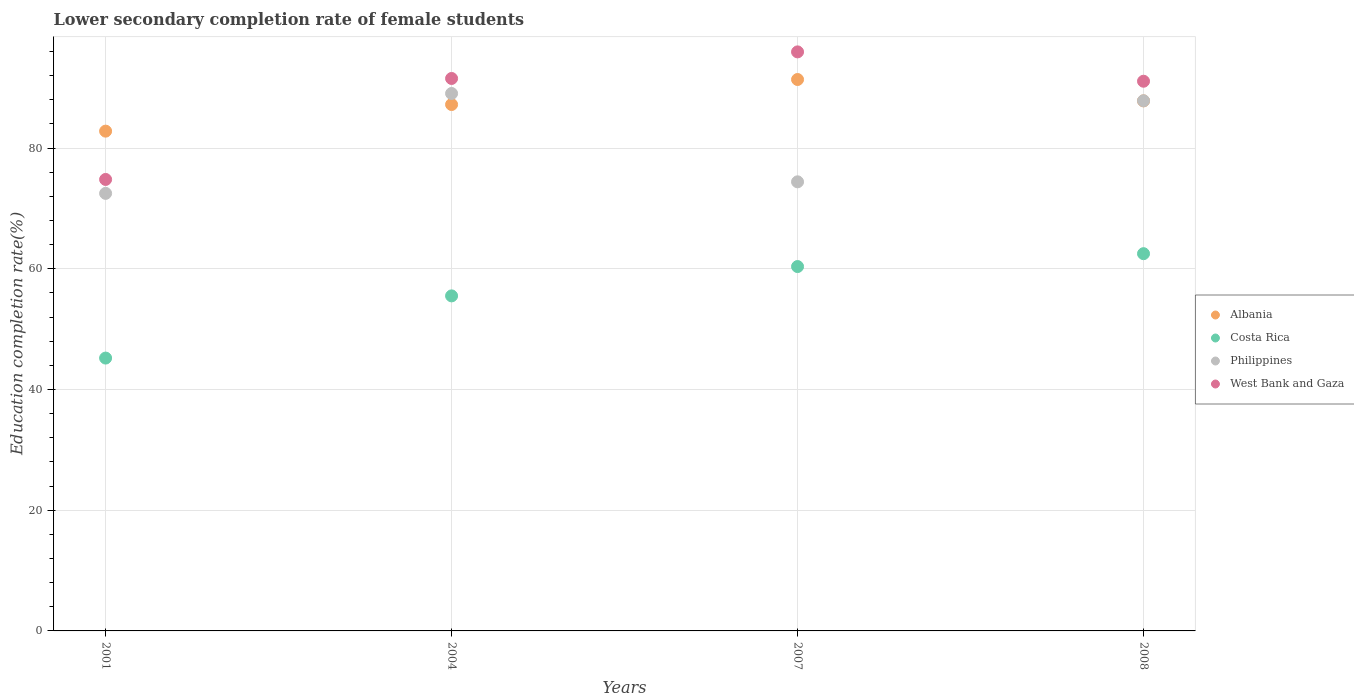Is the number of dotlines equal to the number of legend labels?
Give a very brief answer. Yes. What is the lower secondary completion rate of female students in Albania in 2008?
Offer a terse response. 87.83. Across all years, what is the maximum lower secondary completion rate of female students in Albania?
Ensure brevity in your answer.  91.37. Across all years, what is the minimum lower secondary completion rate of female students in Albania?
Ensure brevity in your answer.  82.82. In which year was the lower secondary completion rate of female students in Costa Rica maximum?
Offer a terse response. 2008. In which year was the lower secondary completion rate of female students in West Bank and Gaza minimum?
Provide a short and direct response. 2001. What is the total lower secondary completion rate of female students in West Bank and Gaza in the graph?
Offer a very short reply. 353.39. What is the difference between the lower secondary completion rate of female students in Philippines in 2001 and that in 2004?
Make the answer very short. -16.55. What is the difference between the lower secondary completion rate of female students in West Bank and Gaza in 2004 and the lower secondary completion rate of female students in Philippines in 2001?
Provide a succinct answer. 19.04. What is the average lower secondary completion rate of female students in West Bank and Gaza per year?
Your answer should be compact. 88.35. In the year 2001, what is the difference between the lower secondary completion rate of female students in Albania and lower secondary completion rate of female students in West Bank and Gaza?
Your response must be concise. 8. What is the ratio of the lower secondary completion rate of female students in Albania in 2004 to that in 2008?
Your answer should be compact. 0.99. Is the lower secondary completion rate of female students in Costa Rica in 2007 less than that in 2008?
Provide a short and direct response. Yes. Is the difference between the lower secondary completion rate of female students in Albania in 2001 and 2008 greater than the difference between the lower secondary completion rate of female students in West Bank and Gaza in 2001 and 2008?
Keep it short and to the point. Yes. What is the difference between the highest and the second highest lower secondary completion rate of female students in Philippines?
Ensure brevity in your answer.  1.2. What is the difference between the highest and the lowest lower secondary completion rate of female students in Philippines?
Make the answer very short. 16.55. Is the sum of the lower secondary completion rate of female students in West Bank and Gaza in 2001 and 2004 greater than the maximum lower secondary completion rate of female students in Costa Rica across all years?
Provide a short and direct response. Yes. Is it the case that in every year, the sum of the lower secondary completion rate of female students in Philippines and lower secondary completion rate of female students in Albania  is greater than the lower secondary completion rate of female students in West Bank and Gaza?
Make the answer very short. Yes. Does the lower secondary completion rate of female students in Philippines monotonically increase over the years?
Your answer should be very brief. No. Is the lower secondary completion rate of female students in West Bank and Gaza strictly greater than the lower secondary completion rate of female students in Albania over the years?
Give a very brief answer. No. Does the graph contain any zero values?
Provide a short and direct response. No. Where does the legend appear in the graph?
Provide a succinct answer. Center right. How many legend labels are there?
Your response must be concise. 4. What is the title of the graph?
Offer a terse response. Lower secondary completion rate of female students. What is the label or title of the Y-axis?
Make the answer very short. Education completion rate(%). What is the Education completion rate(%) of Albania in 2001?
Your response must be concise. 82.82. What is the Education completion rate(%) of Costa Rica in 2001?
Provide a short and direct response. 45.21. What is the Education completion rate(%) in Philippines in 2001?
Make the answer very short. 72.5. What is the Education completion rate(%) of West Bank and Gaza in 2001?
Your answer should be very brief. 74.81. What is the Education completion rate(%) in Albania in 2004?
Ensure brevity in your answer.  87.23. What is the Education completion rate(%) in Costa Rica in 2004?
Make the answer very short. 55.52. What is the Education completion rate(%) in Philippines in 2004?
Provide a short and direct response. 89.05. What is the Education completion rate(%) in West Bank and Gaza in 2004?
Ensure brevity in your answer.  91.54. What is the Education completion rate(%) in Albania in 2007?
Your answer should be compact. 91.37. What is the Education completion rate(%) of Costa Rica in 2007?
Keep it short and to the point. 60.38. What is the Education completion rate(%) in Philippines in 2007?
Make the answer very short. 74.42. What is the Education completion rate(%) in West Bank and Gaza in 2007?
Your answer should be very brief. 95.95. What is the Education completion rate(%) in Albania in 2008?
Offer a very short reply. 87.83. What is the Education completion rate(%) of Costa Rica in 2008?
Provide a succinct answer. 62.51. What is the Education completion rate(%) of Philippines in 2008?
Your answer should be very brief. 87.85. What is the Education completion rate(%) of West Bank and Gaza in 2008?
Provide a succinct answer. 91.09. Across all years, what is the maximum Education completion rate(%) in Albania?
Your answer should be compact. 91.37. Across all years, what is the maximum Education completion rate(%) in Costa Rica?
Your answer should be compact. 62.51. Across all years, what is the maximum Education completion rate(%) in Philippines?
Provide a short and direct response. 89.05. Across all years, what is the maximum Education completion rate(%) of West Bank and Gaza?
Provide a short and direct response. 95.95. Across all years, what is the minimum Education completion rate(%) of Albania?
Provide a succinct answer. 82.82. Across all years, what is the minimum Education completion rate(%) in Costa Rica?
Keep it short and to the point. 45.21. Across all years, what is the minimum Education completion rate(%) in Philippines?
Offer a very short reply. 72.5. Across all years, what is the minimum Education completion rate(%) of West Bank and Gaza?
Your response must be concise. 74.81. What is the total Education completion rate(%) in Albania in the graph?
Offer a terse response. 349.25. What is the total Education completion rate(%) of Costa Rica in the graph?
Keep it short and to the point. 223.62. What is the total Education completion rate(%) in Philippines in the graph?
Keep it short and to the point. 323.83. What is the total Education completion rate(%) in West Bank and Gaza in the graph?
Keep it short and to the point. 353.39. What is the difference between the Education completion rate(%) in Albania in 2001 and that in 2004?
Give a very brief answer. -4.41. What is the difference between the Education completion rate(%) of Costa Rica in 2001 and that in 2004?
Offer a very short reply. -10.31. What is the difference between the Education completion rate(%) in Philippines in 2001 and that in 2004?
Your answer should be compact. -16.55. What is the difference between the Education completion rate(%) in West Bank and Gaza in 2001 and that in 2004?
Make the answer very short. -16.73. What is the difference between the Education completion rate(%) in Albania in 2001 and that in 2007?
Give a very brief answer. -8.56. What is the difference between the Education completion rate(%) in Costa Rica in 2001 and that in 2007?
Give a very brief answer. -15.17. What is the difference between the Education completion rate(%) in Philippines in 2001 and that in 2007?
Offer a very short reply. -1.91. What is the difference between the Education completion rate(%) in West Bank and Gaza in 2001 and that in 2007?
Give a very brief answer. -21.14. What is the difference between the Education completion rate(%) in Albania in 2001 and that in 2008?
Your answer should be very brief. -5.02. What is the difference between the Education completion rate(%) in Costa Rica in 2001 and that in 2008?
Provide a short and direct response. -17.3. What is the difference between the Education completion rate(%) in Philippines in 2001 and that in 2008?
Provide a short and direct response. -15.35. What is the difference between the Education completion rate(%) of West Bank and Gaza in 2001 and that in 2008?
Keep it short and to the point. -16.27. What is the difference between the Education completion rate(%) of Albania in 2004 and that in 2007?
Your response must be concise. -4.15. What is the difference between the Education completion rate(%) of Costa Rica in 2004 and that in 2007?
Provide a short and direct response. -4.86. What is the difference between the Education completion rate(%) in Philippines in 2004 and that in 2007?
Your answer should be compact. 14.64. What is the difference between the Education completion rate(%) in West Bank and Gaza in 2004 and that in 2007?
Your response must be concise. -4.41. What is the difference between the Education completion rate(%) in Albania in 2004 and that in 2008?
Make the answer very short. -0.6. What is the difference between the Education completion rate(%) in Costa Rica in 2004 and that in 2008?
Your answer should be very brief. -6.99. What is the difference between the Education completion rate(%) of Philippines in 2004 and that in 2008?
Keep it short and to the point. 1.2. What is the difference between the Education completion rate(%) in West Bank and Gaza in 2004 and that in 2008?
Give a very brief answer. 0.46. What is the difference between the Education completion rate(%) in Albania in 2007 and that in 2008?
Keep it short and to the point. 3.54. What is the difference between the Education completion rate(%) in Costa Rica in 2007 and that in 2008?
Ensure brevity in your answer.  -2.13. What is the difference between the Education completion rate(%) in Philippines in 2007 and that in 2008?
Your answer should be very brief. -13.43. What is the difference between the Education completion rate(%) in West Bank and Gaza in 2007 and that in 2008?
Give a very brief answer. 4.86. What is the difference between the Education completion rate(%) in Albania in 2001 and the Education completion rate(%) in Costa Rica in 2004?
Give a very brief answer. 27.3. What is the difference between the Education completion rate(%) of Albania in 2001 and the Education completion rate(%) of Philippines in 2004?
Your answer should be very brief. -6.24. What is the difference between the Education completion rate(%) in Albania in 2001 and the Education completion rate(%) in West Bank and Gaza in 2004?
Give a very brief answer. -8.73. What is the difference between the Education completion rate(%) in Costa Rica in 2001 and the Education completion rate(%) in Philippines in 2004?
Your answer should be compact. -43.84. What is the difference between the Education completion rate(%) in Costa Rica in 2001 and the Education completion rate(%) in West Bank and Gaza in 2004?
Keep it short and to the point. -46.33. What is the difference between the Education completion rate(%) in Philippines in 2001 and the Education completion rate(%) in West Bank and Gaza in 2004?
Provide a succinct answer. -19.04. What is the difference between the Education completion rate(%) of Albania in 2001 and the Education completion rate(%) of Costa Rica in 2007?
Offer a terse response. 22.44. What is the difference between the Education completion rate(%) in Albania in 2001 and the Education completion rate(%) in Philippines in 2007?
Ensure brevity in your answer.  8.4. What is the difference between the Education completion rate(%) in Albania in 2001 and the Education completion rate(%) in West Bank and Gaza in 2007?
Provide a succinct answer. -13.13. What is the difference between the Education completion rate(%) in Costa Rica in 2001 and the Education completion rate(%) in Philippines in 2007?
Your answer should be compact. -29.21. What is the difference between the Education completion rate(%) in Costa Rica in 2001 and the Education completion rate(%) in West Bank and Gaza in 2007?
Make the answer very short. -50.74. What is the difference between the Education completion rate(%) in Philippines in 2001 and the Education completion rate(%) in West Bank and Gaza in 2007?
Your answer should be very brief. -23.45. What is the difference between the Education completion rate(%) of Albania in 2001 and the Education completion rate(%) of Costa Rica in 2008?
Ensure brevity in your answer.  20.3. What is the difference between the Education completion rate(%) in Albania in 2001 and the Education completion rate(%) in Philippines in 2008?
Ensure brevity in your answer.  -5.04. What is the difference between the Education completion rate(%) of Albania in 2001 and the Education completion rate(%) of West Bank and Gaza in 2008?
Your answer should be very brief. -8.27. What is the difference between the Education completion rate(%) in Costa Rica in 2001 and the Education completion rate(%) in Philippines in 2008?
Your answer should be compact. -42.64. What is the difference between the Education completion rate(%) of Costa Rica in 2001 and the Education completion rate(%) of West Bank and Gaza in 2008?
Give a very brief answer. -45.87. What is the difference between the Education completion rate(%) in Philippines in 2001 and the Education completion rate(%) in West Bank and Gaza in 2008?
Your answer should be very brief. -18.58. What is the difference between the Education completion rate(%) in Albania in 2004 and the Education completion rate(%) in Costa Rica in 2007?
Offer a terse response. 26.85. What is the difference between the Education completion rate(%) of Albania in 2004 and the Education completion rate(%) of Philippines in 2007?
Offer a terse response. 12.81. What is the difference between the Education completion rate(%) in Albania in 2004 and the Education completion rate(%) in West Bank and Gaza in 2007?
Your answer should be compact. -8.72. What is the difference between the Education completion rate(%) of Costa Rica in 2004 and the Education completion rate(%) of Philippines in 2007?
Give a very brief answer. -18.9. What is the difference between the Education completion rate(%) of Costa Rica in 2004 and the Education completion rate(%) of West Bank and Gaza in 2007?
Provide a succinct answer. -40.43. What is the difference between the Education completion rate(%) of Philippines in 2004 and the Education completion rate(%) of West Bank and Gaza in 2007?
Keep it short and to the point. -6.89. What is the difference between the Education completion rate(%) of Albania in 2004 and the Education completion rate(%) of Costa Rica in 2008?
Your answer should be compact. 24.72. What is the difference between the Education completion rate(%) of Albania in 2004 and the Education completion rate(%) of Philippines in 2008?
Offer a very short reply. -0.63. What is the difference between the Education completion rate(%) of Albania in 2004 and the Education completion rate(%) of West Bank and Gaza in 2008?
Your answer should be compact. -3.86. What is the difference between the Education completion rate(%) of Costa Rica in 2004 and the Education completion rate(%) of Philippines in 2008?
Provide a short and direct response. -32.33. What is the difference between the Education completion rate(%) of Costa Rica in 2004 and the Education completion rate(%) of West Bank and Gaza in 2008?
Make the answer very short. -35.57. What is the difference between the Education completion rate(%) of Philippines in 2004 and the Education completion rate(%) of West Bank and Gaza in 2008?
Offer a terse response. -2.03. What is the difference between the Education completion rate(%) of Albania in 2007 and the Education completion rate(%) of Costa Rica in 2008?
Offer a terse response. 28.86. What is the difference between the Education completion rate(%) in Albania in 2007 and the Education completion rate(%) in Philippines in 2008?
Your response must be concise. 3.52. What is the difference between the Education completion rate(%) in Albania in 2007 and the Education completion rate(%) in West Bank and Gaza in 2008?
Provide a short and direct response. 0.29. What is the difference between the Education completion rate(%) of Costa Rica in 2007 and the Education completion rate(%) of Philippines in 2008?
Your response must be concise. -27.47. What is the difference between the Education completion rate(%) in Costa Rica in 2007 and the Education completion rate(%) in West Bank and Gaza in 2008?
Give a very brief answer. -30.71. What is the difference between the Education completion rate(%) of Philippines in 2007 and the Education completion rate(%) of West Bank and Gaza in 2008?
Ensure brevity in your answer.  -16.67. What is the average Education completion rate(%) in Albania per year?
Ensure brevity in your answer.  87.31. What is the average Education completion rate(%) in Costa Rica per year?
Ensure brevity in your answer.  55.9. What is the average Education completion rate(%) of Philippines per year?
Offer a terse response. 80.96. What is the average Education completion rate(%) of West Bank and Gaza per year?
Provide a short and direct response. 88.35. In the year 2001, what is the difference between the Education completion rate(%) in Albania and Education completion rate(%) in Costa Rica?
Offer a very short reply. 37.6. In the year 2001, what is the difference between the Education completion rate(%) of Albania and Education completion rate(%) of Philippines?
Offer a terse response. 10.31. In the year 2001, what is the difference between the Education completion rate(%) of Albania and Education completion rate(%) of West Bank and Gaza?
Keep it short and to the point. 8. In the year 2001, what is the difference between the Education completion rate(%) in Costa Rica and Education completion rate(%) in Philippines?
Your answer should be compact. -27.29. In the year 2001, what is the difference between the Education completion rate(%) of Costa Rica and Education completion rate(%) of West Bank and Gaza?
Make the answer very short. -29.6. In the year 2001, what is the difference between the Education completion rate(%) of Philippines and Education completion rate(%) of West Bank and Gaza?
Make the answer very short. -2.31. In the year 2004, what is the difference between the Education completion rate(%) of Albania and Education completion rate(%) of Costa Rica?
Your answer should be very brief. 31.71. In the year 2004, what is the difference between the Education completion rate(%) of Albania and Education completion rate(%) of Philippines?
Offer a very short reply. -1.83. In the year 2004, what is the difference between the Education completion rate(%) of Albania and Education completion rate(%) of West Bank and Gaza?
Provide a succinct answer. -4.32. In the year 2004, what is the difference between the Education completion rate(%) in Costa Rica and Education completion rate(%) in Philippines?
Your response must be concise. -33.54. In the year 2004, what is the difference between the Education completion rate(%) of Costa Rica and Education completion rate(%) of West Bank and Gaza?
Make the answer very short. -36.03. In the year 2004, what is the difference between the Education completion rate(%) in Philippines and Education completion rate(%) in West Bank and Gaza?
Give a very brief answer. -2.49. In the year 2007, what is the difference between the Education completion rate(%) of Albania and Education completion rate(%) of Costa Rica?
Offer a terse response. 31. In the year 2007, what is the difference between the Education completion rate(%) of Albania and Education completion rate(%) of Philippines?
Provide a short and direct response. 16.96. In the year 2007, what is the difference between the Education completion rate(%) in Albania and Education completion rate(%) in West Bank and Gaza?
Keep it short and to the point. -4.58. In the year 2007, what is the difference between the Education completion rate(%) of Costa Rica and Education completion rate(%) of Philippines?
Make the answer very short. -14.04. In the year 2007, what is the difference between the Education completion rate(%) in Costa Rica and Education completion rate(%) in West Bank and Gaza?
Make the answer very short. -35.57. In the year 2007, what is the difference between the Education completion rate(%) of Philippines and Education completion rate(%) of West Bank and Gaza?
Your response must be concise. -21.53. In the year 2008, what is the difference between the Education completion rate(%) in Albania and Education completion rate(%) in Costa Rica?
Provide a short and direct response. 25.32. In the year 2008, what is the difference between the Education completion rate(%) of Albania and Education completion rate(%) of Philippines?
Keep it short and to the point. -0.02. In the year 2008, what is the difference between the Education completion rate(%) in Albania and Education completion rate(%) in West Bank and Gaza?
Provide a short and direct response. -3.26. In the year 2008, what is the difference between the Education completion rate(%) of Costa Rica and Education completion rate(%) of Philippines?
Your response must be concise. -25.34. In the year 2008, what is the difference between the Education completion rate(%) of Costa Rica and Education completion rate(%) of West Bank and Gaza?
Provide a succinct answer. -28.58. In the year 2008, what is the difference between the Education completion rate(%) in Philippines and Education completion rate(%) in West Bank and Gaza?
Offer a terse response. -3.23. What is the ratio of the Education completion rate(%) in Albania in 2001 to that in 2004?
Your response must be concise. 0.95. What is the ratio of the Education completion rate(%) in Costa Rica in 2001 to that in 2004?
Your response must be concise. 0.81. What is the ratio of the Education completion rate(%) of Philippines in 2001 to that in 2004?
Provide a short and direct response. 0.81. What is the ratio of the Education completion rate(%) of West Bank and Gaza in 2001 to that in 2004?
Ensure brevity in your answer.  0.82. What is the ratio of the Education completion rate(%) in Albania in 2001 to that in 2007?
Give a very brief answer. 0.91. What is the ratio of the Education completion rate(%) of Costa Rica in 2001 to that in 2007?
Provide a short and direct response. 0.75. What is the ratio of the Education completion rate(%) in Philippines in 2001 to that in 2007?
Give a very brief answer. 0.97. What is the ratio of the Education completion rate(%) of West Bank and Gaza in 2001 to that in 2007?
Offer a very short reply. 0.78. What is the ratio of the Education completion rate(%) in Albania in 2001 to that in 2008?
Your answer should be very brief. 0.94. What is the ratio of the Education completion rate(%) of Costa Rica in 2001 to that in 2008?
Your answer should be compact. 0.72. What is the ratio of the Education completion rate(%) in Philippines in 2001 to that in 2008?
Give a very brief answer. 0.83. What is the ratio of the Education completion rate(%) of West Bank and Gaza in 2001 to that in 2008?
Make the answer very short. 0.82. What is the ratio of the Education completion rate(%) of Albania in 2004 to that in 2007?
Make the answer very short. 0.95. What is the ratio of the Education completion rate(%) of Costa Rica in 2004 to that in 2007?
Offer a terse response. 0.92. What is the ratio of the Education completion rate(%) of Philippines in 2004 to that in 2007?
Keep it short and to the point. 1.2. What is the ratio of the Education completion rate(%) of West Bank and Gaza in 2004 to that in 2007?
Ensure brevity in your answer.  0.95. What is the ratio of the Education completion rate(%) in Albania in 2004 to that in 2008?
Provide a short and direct response. 0.99. What is the ratio of the Education completion rate(%) in Costa Rica in 2004 to that in 2008?
Ensure brevity in your answer.  0.89. What is the ratio of the Education completion rate(%) in Philippines in 2004 to that in 2008?
Your answer should be very brief. 1.01. What is the ratio of the Education completion rate(%) in Albania in 2007 to that in 2008?
Make the answer very short. 1.04. What is the ratio of the Education completion rate(%) in Costa Rica in 2007 to that in 2008?
Offer a very short reply. 0.97. What is the ratio of the Education completion rate(%) in Philippines in 2007 to that in 2008?
Give a very brief answer. 0.85. What is the ratio of the Education completion rate(%) of West Bank and Gaza in 2007 to that in 2008?
Offer a terse response. 1.05. What is the difference between the highest and the second highest Education completion rate(%) of Albania?
Your answer should be very brief. 3.54. What is the difference between the highest and the second highest Education completion rate(%) in Costa Rica?
Your answer should be very brief. 2.13. What is the difference between the highest and the second highest Education completion rate(%) in Philippines?
Your answer should be compact. 1.2. What is the difference between the highest and the second highest Education completion rate(%) in West Bank and Gaza?
Make the answer very short. 4.41. What is the difference between the highest and the lowest Education completion rate(%) of Albania?
Ensure brevity in your answer.  8.56. What is the difference between the highest and the lowest Education completion rate(%) of Costa Rica?
Your response must be concise. 17.3. What is the difference between the highest and the lowest Education completion rate(%) in Philippines?
Keep it short and to the point. 16.55. What is the difference between the highest and the lowest Education completion rate(%) in West Bank and Gaza?
Provide a short and direct response. 21.14. 